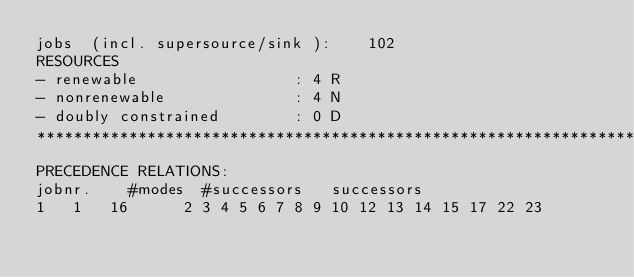Convert code to text. <code><loc_0><loc_0><loc_500><loc_500><_ObjectiveC_>jobs  (incl. supersource/sink ):	102
RESOURCES
- renewable                 : 4 R
- nonrenewable              : 4 N
- doubly constrained        : 0 D
************************************************************************
PRECEDENCE RELATIONS:
jobnr.    #modes  #successors   successors
1	1	16		2 3 4 5 6 7 8 9 10 12 13 14 15 17 22 23 </code> 